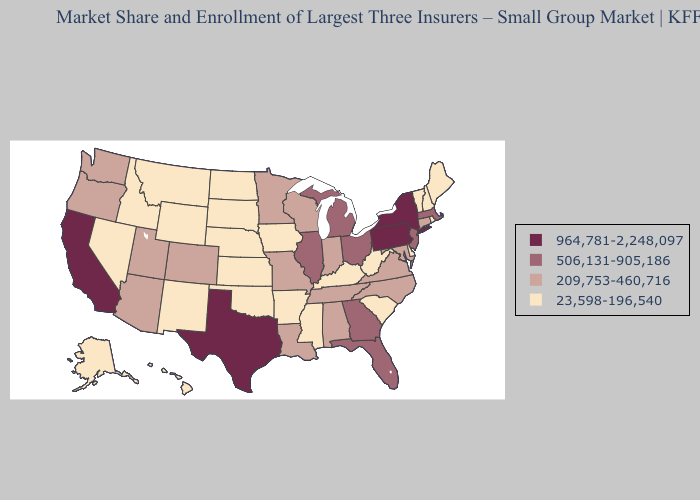Is the legend a continuous bar?
Give a very brief answer. No. What is the lowest value in states that border Missouri?
Answer briefly. 23,598-196,540. Name the states that have a value in the range 23,598-196,540?
Answer briefly. Alaska, Arkansas, Delaware, Hawaii, Idaho, Iowa, Kansas, Kentucky, Maine, Mississippi, Montana, Nebraska, Nevada, New Hampshire, New Mexico, North Dakota, Oklahoma, Rhode Island, South Carolina, South Dakota, Vermont, West Virginia, Wyoming. What is the lowest value in states that border Mississippi?
Give a very brief answer. 23,598-196,540. What is the lowest value in states that border Tennessee?
Keep it brief. 23,598-196,540. What is the value of California?
Write a very short answer. 964,781-2,248,097. Does Alaska have the lowest value in the USA?
Keep it brief. Yes. What is the highest value in the South ?
Quick response, please. 964,781-2,248,097. Name the states that have a value in the range 964,781-2,248,097?
Short answer required. California, New York, Pennsylvania, Texas. What is the value of Texas?
Answer briefly. 964,781-2,248,097. Does the map have missing data?
Write a very short answer. No. What is the highest value in the USA?
Short answer required. 964,781-2,248,097. What is the value of Utah?
Be succinct. 209,753-460,716. What is the value of Ohio?
Quick response, please. 506,131-905,186. Does Maine have a lower value than Texas?
Concise answer only. Yes. 